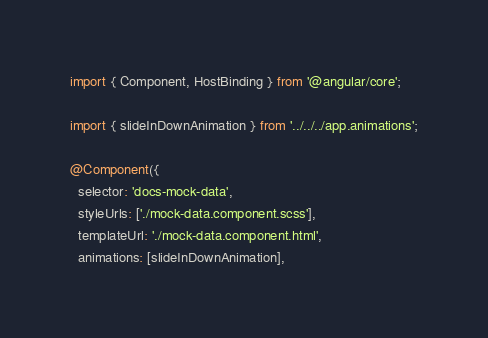<code> <loc_0><loc_0><loc_500><loc_500><_TypeScript_>import { Component, HostBinding } from '@angular/core';

import { slideInDownAnimation } from '../../../app.animations';

@Component({
  selector: 'docs-mock-data',
  styleUrls: ['./mock-data.component.scss'],
  templateUrl: './mock-data.component.html',
  animations: [slideInDownAnimation],</code> 